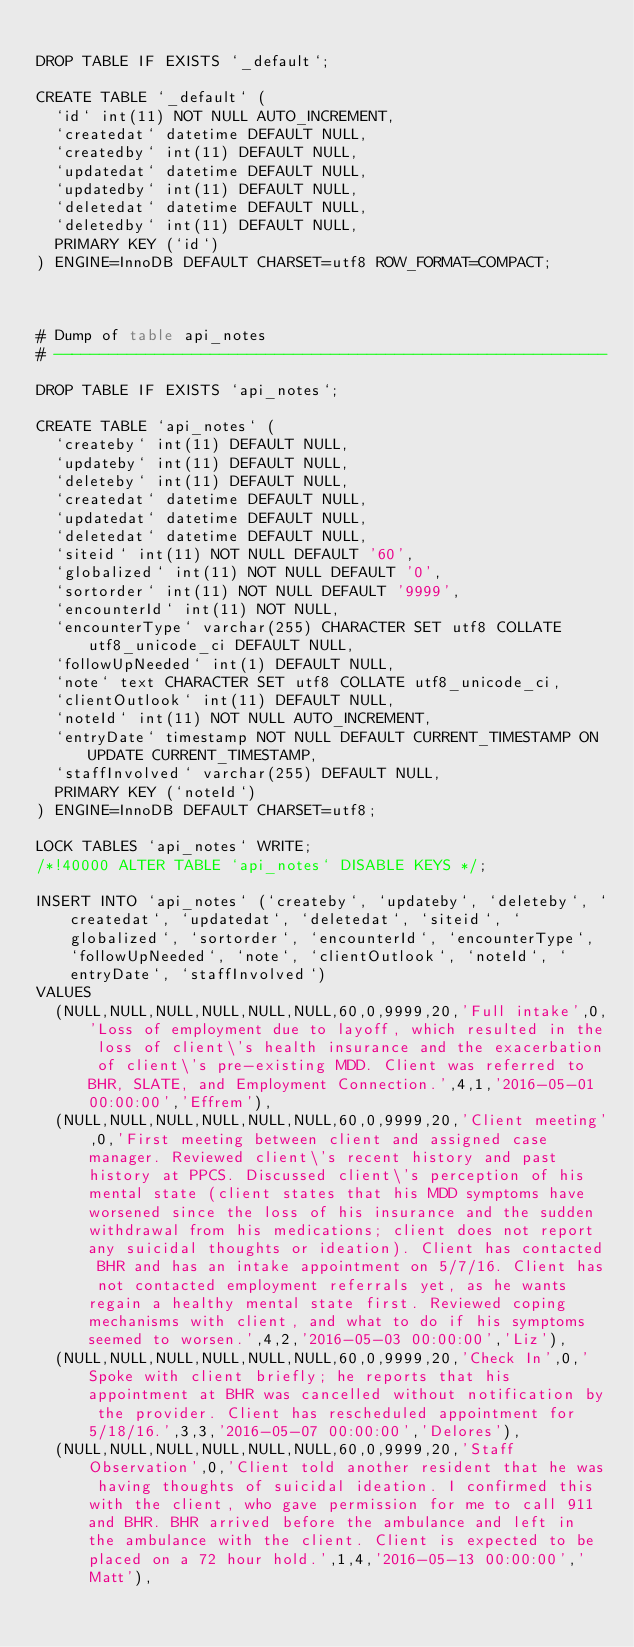Convert code to text. <code><loc_0><loc_0><loc_500><loc_500><_SQL_>
DROP TABLE IF EXISTS `_default`;

CREATE TABLE `_default` (
  `id` int(11) NOT NULL AUTO_INCREMENT,
  `createdat` datetime DEFAULT NULL,
  `createdby` int(11) DEFAULT NULL,
  `updatedat` datetime DEFAULT NULL,
  `updatedby` int(11) DEFAULT NULL,
  `deletedat` datetime DEFAULT NULL,
  `deletedby` int(11) DEFAULT NULL,
  PRIMARY KEY (`id`)
) ENGINE=InnoDB DEFAULT CHARSET=utf8 ROW_FORMAT=COMPACT;



# Dump of table api_notes
# ------------------------------------------------------------

DROP TABLE IF EXISTS `api_notes`;

CREATE TABLE `api_notes` (
  `createby` int(11) DEFAULT NULL,
  `updateby` int(11) DEFAULT NULL,
  `deleteby` int(11) DEFAULT NULL,
  `createdat` datetime DEFAULT NULL,
  `updatedat` datetime DEFAULT NULL,
  `deletedat` datetime DEFAULT NULL,
  `siteid` int(11) NOT NULL DEFAULT '60',
  `globalized` int(11) NOT NULL DEFAULT '0',
  `sortorder` int(11) NOT NULL DEFAULT '9999',
  `encounterId` int(11) NOT NULL,
  `encounterType` varchar(255) CHARACTER SET utf8 COLLATE utf8_unicode_ci DEFAULT NULL,
  `followUpNeeded` int(1) DEFAULT NULL,
  `note` text CHARACTER SET utf8 COLLATE utf8_unicode_ci,
  `clientOutlook` int(11) DEFAULT NULL,
  `noteId` int(11) NOT NULL AUTO_INCREMENT,
  `entryDate` timestamp NOT NULL DEFAULT CURRENT_TIMESTAMP ON UPDATE CURRENT_TIMESTAMP,
  `staffInvolved` varchar(255) DEFAULT NULL,
  PRIMARY KEY (`noteId`)
) ENGINE=InnoDB DEFAULT CHARSET=utf8;

LOCK TABLES `api_notes` WRITE;
/*!40000 ALTER TABLE `api_notes` DISABLE KEYS */;

INSERT INTO `api_notes` (`createby`, `updateby`, `deleteby`, `createdat`, `updatedat`, `deletedat`, `siteid`, `globalized`, `sortorder`, `encounterId`, `encounterType`, `followUpNeeded`, `note`, `clientOutlook`, `noteId`, `entryDate`, `staffInvolved`)
VALUES
	(NULL,NULL,NULL,NULL,NULL,NULL,60,0,9999,20,'Full intake',0,'Loss of employment due to layoff, which resulted in the loss of client\'s health insurance and the exacerbation of client\'s pre-existing MDD. Client was referred to BHR, SLATE, and Employment Connection.',4,1,'2016-05-01 00:00:00','Effrem'),
	(NULL,NULL,NULL,NULL,NULL,NULL,60,0,9999,20,'Client meeting',0,'First meeting between client and assigned case manager. Reviewed client\'s recent history and past history at PPCS. Discussed client\'s perception of his mental state (client states that his MDD symptoms have worsened since the loss of his insurance and the sudden withdrawal from his medications; client does not report any suicidal thoughts or ideation). Client has contacted BHR and has an intake appointment on 5/7/16. Client has not contacted employment referrals yet, as he wants regain a healthy mental state first. Reviewed coping mechanisms with client, and what to do if his symptoms seemed to worsen.',4,2,'2016-05-03 00:00:00','Liz'),
	(NULL,NULL,NULL,NULL,NULL,NULL,60,0,9999,20,'Check In',0,'Spoke with client briefly; he reports that his appointment at BHR was cancelled without notification by the provider. Client has rescheduled appointment for 5/18/16.',3,3,'2016-05-07 00:00:00','Delores'),
	(NULL,NULL,NULL,NULL,NULL,NULL,60,0,9999,20,'Staff Observation',0,'Client told another resident that he was having thoughts of suicidal ideation. I confirmed this with the client, who gave permission for me to call 911 and BHR. BHR arrived before the ambulance and left in the ambulance with the client. Client is expected to be placed on a 72 hour hold.',1,4,'2016-05-13 00:00:00','Matt'),</code> 